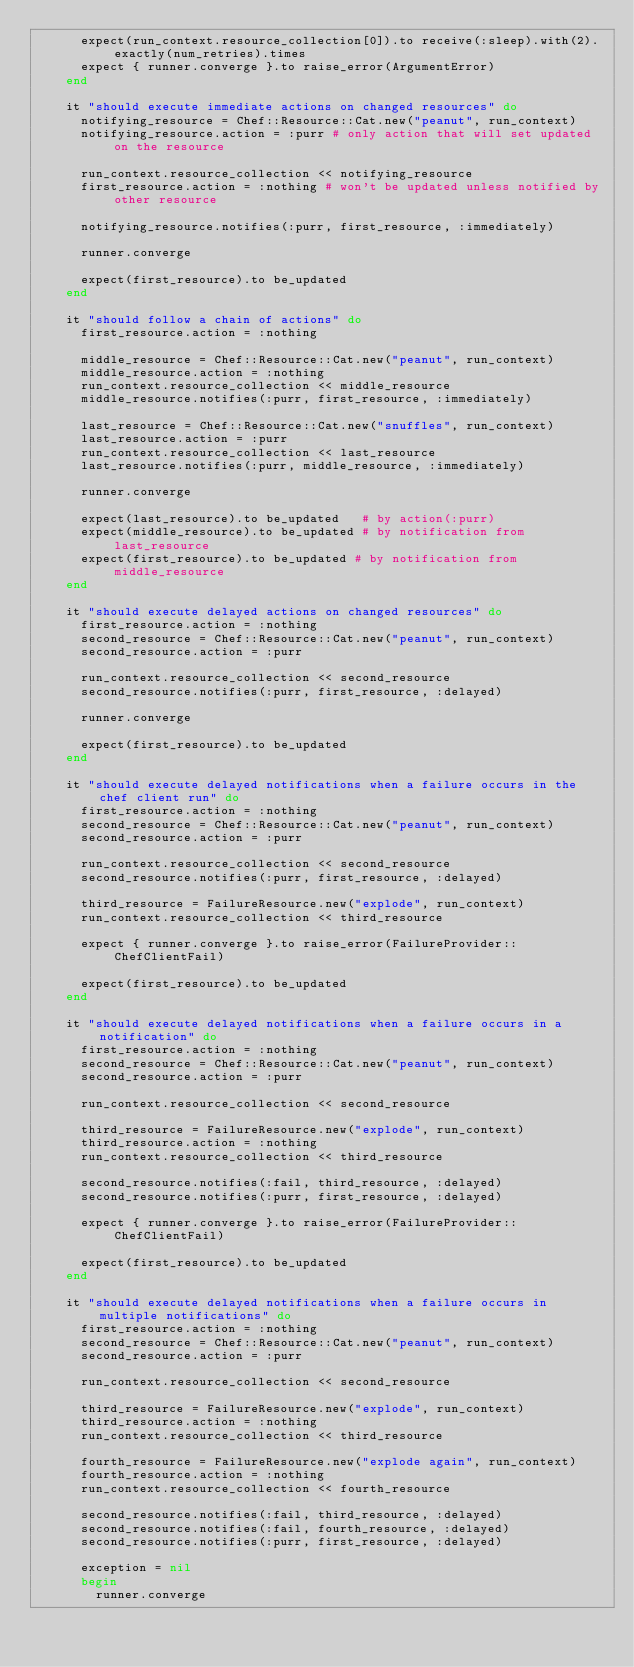<code> <loc_0><loc_0><loc_500><loc_500><_Ruby_>      expect(run_context.resource_collection[0]).to receive(:sleep).with(2).exactly(num_retries).times
      expect { runner.converge }.to raise_error(ArgumentError)
    end

    it "should execute immediate actions on changed resources" do
      notifying_resource = Chef::Resource::Cat.new("peanut", run_context)
      notifying_resource.action = :purr # only action that will set updated on the resource

      run_context.resource_collection << notifying_resource
      first_resource.action = :nothing # won't be updated unless notified by other resource

      notifying_resource.notifies(:purr, first_resource, :immediately)

      runner.converge

      expect(first_resource).to be_updated
    end

    it "should follow a chain of actions" do
      first_resource.action = :nothing

      middle_resource = Chef::Resource::Cat.new("peanut", run_context)
      middle_resource.action = :nothing
      run_context.resource_collection << middle_resource
      middle_resource.notifies(:purr, first_resource, :immediately)

      last_resource = Chef::Resource::Cat.new("snuffles", run_context)
      last_resource.action = :purr
      run_context.resource_collection << last_resource
      last_resource.notifies(:purr, middle_resource, :immediately)

      runner.converge

      expect(last_resource).to be_updated   # by action(:purr)
      expect(middle_resource).to be_updated # by notification from last_resource
      expect(first_resource).to be_updated # by notification from middle_resource
    end

    it "should execute delayed actions on changed resources" do
      first_resource.action = :nothing
      second_resource = Chef::Resource::Cat.new("peanut", run_context)
      second_resource.action = :purr

      run_context.resource_collection << second_resource
      second_resource.notifies(:purr, first_resource, :delayed)

      runner.converge

      expect(first_resource).to be_updated
    end

    it "should execute delayed notifications when a failure occurs in the chef client run" do
      first_resource.action = :nothing
      second_resource = Chef::Resource::Cat.new("peanut", run_context)
      second_resource.action = :purr

      run_context.resource_collection << second_resource
      second_resource.notifies(:purr, first_resource, :delayed)

      third_resource = FailureResource.new("explode", run_context)
      run_context.resource_collection << third_resource

      expect { runner.converge }.to raise_error(FailureProvider::ChefClientFail)

      expect(first_resource).to be_updated
    end

    it "should execute delayed notifications when a failure occurs in a notification" do
      first_resource.action = :nothing
      second_resource = Chef::Resource::Cat.new("peanut", run_context)
      second_resource.action = :purr

      run_context.resource_collection << second_resource

      third_resource = FailureResource.new("explode", run_context)
      third_resource.action = :nothing
      run_context.resource_collection << third_resource

      second_resource.notifies(:fail, third_resource, :delayed)
      second_resource.notifies(:purr, first_resource, :delayed)

      expect { runner.converge }.to raise_error(FailureProvider::ChefClientFail)

      expect(first_resource).to be_updated
    end

    it "should execute delayed notifications when a failure occurs in multiple notifications" do
      first_resource.action = :nothing
      second_resource = Chef::Resource::Cat.new("peanut", run_context)
      second_resource.action = :purr

      run_context.resource_collection << second_resource

      third_resource = FailureResource.new("explode", run_context)
      third_resource.action = :nothing
      run_context.resource_collection << third_resource

      fourth_resource = FailureResource.new("explode again", run_context)
      fourth_resource.action = :nothing
      run_context.resource_collection << fourth_resource

      second_resource.notifies(:fail, third_resource, :delayed)
      second_resource.notifies(:fail, fourth_resource, :delayed)
      second_resource.notifies(:purr, first_resource, :delayed)

      exception = nil
      begin
        runner.converge</code> 